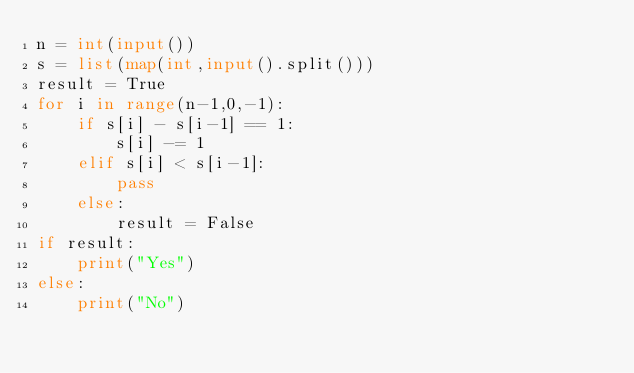Convert code to text. <code><loc_0><loc_0><loc_500><loc_500><_Python_>n = int(input())
s = list(map(int,input().split()))
result = True
for i in range(n-1,0,-1):
    if s[i] - s[i-1] == 1:
        s[i] -= 1
    elif s[i] < s[i-1]:
        pass
    else:
        result = False 
if result:
    print("Yes")
else:
    print("No")
</code> 